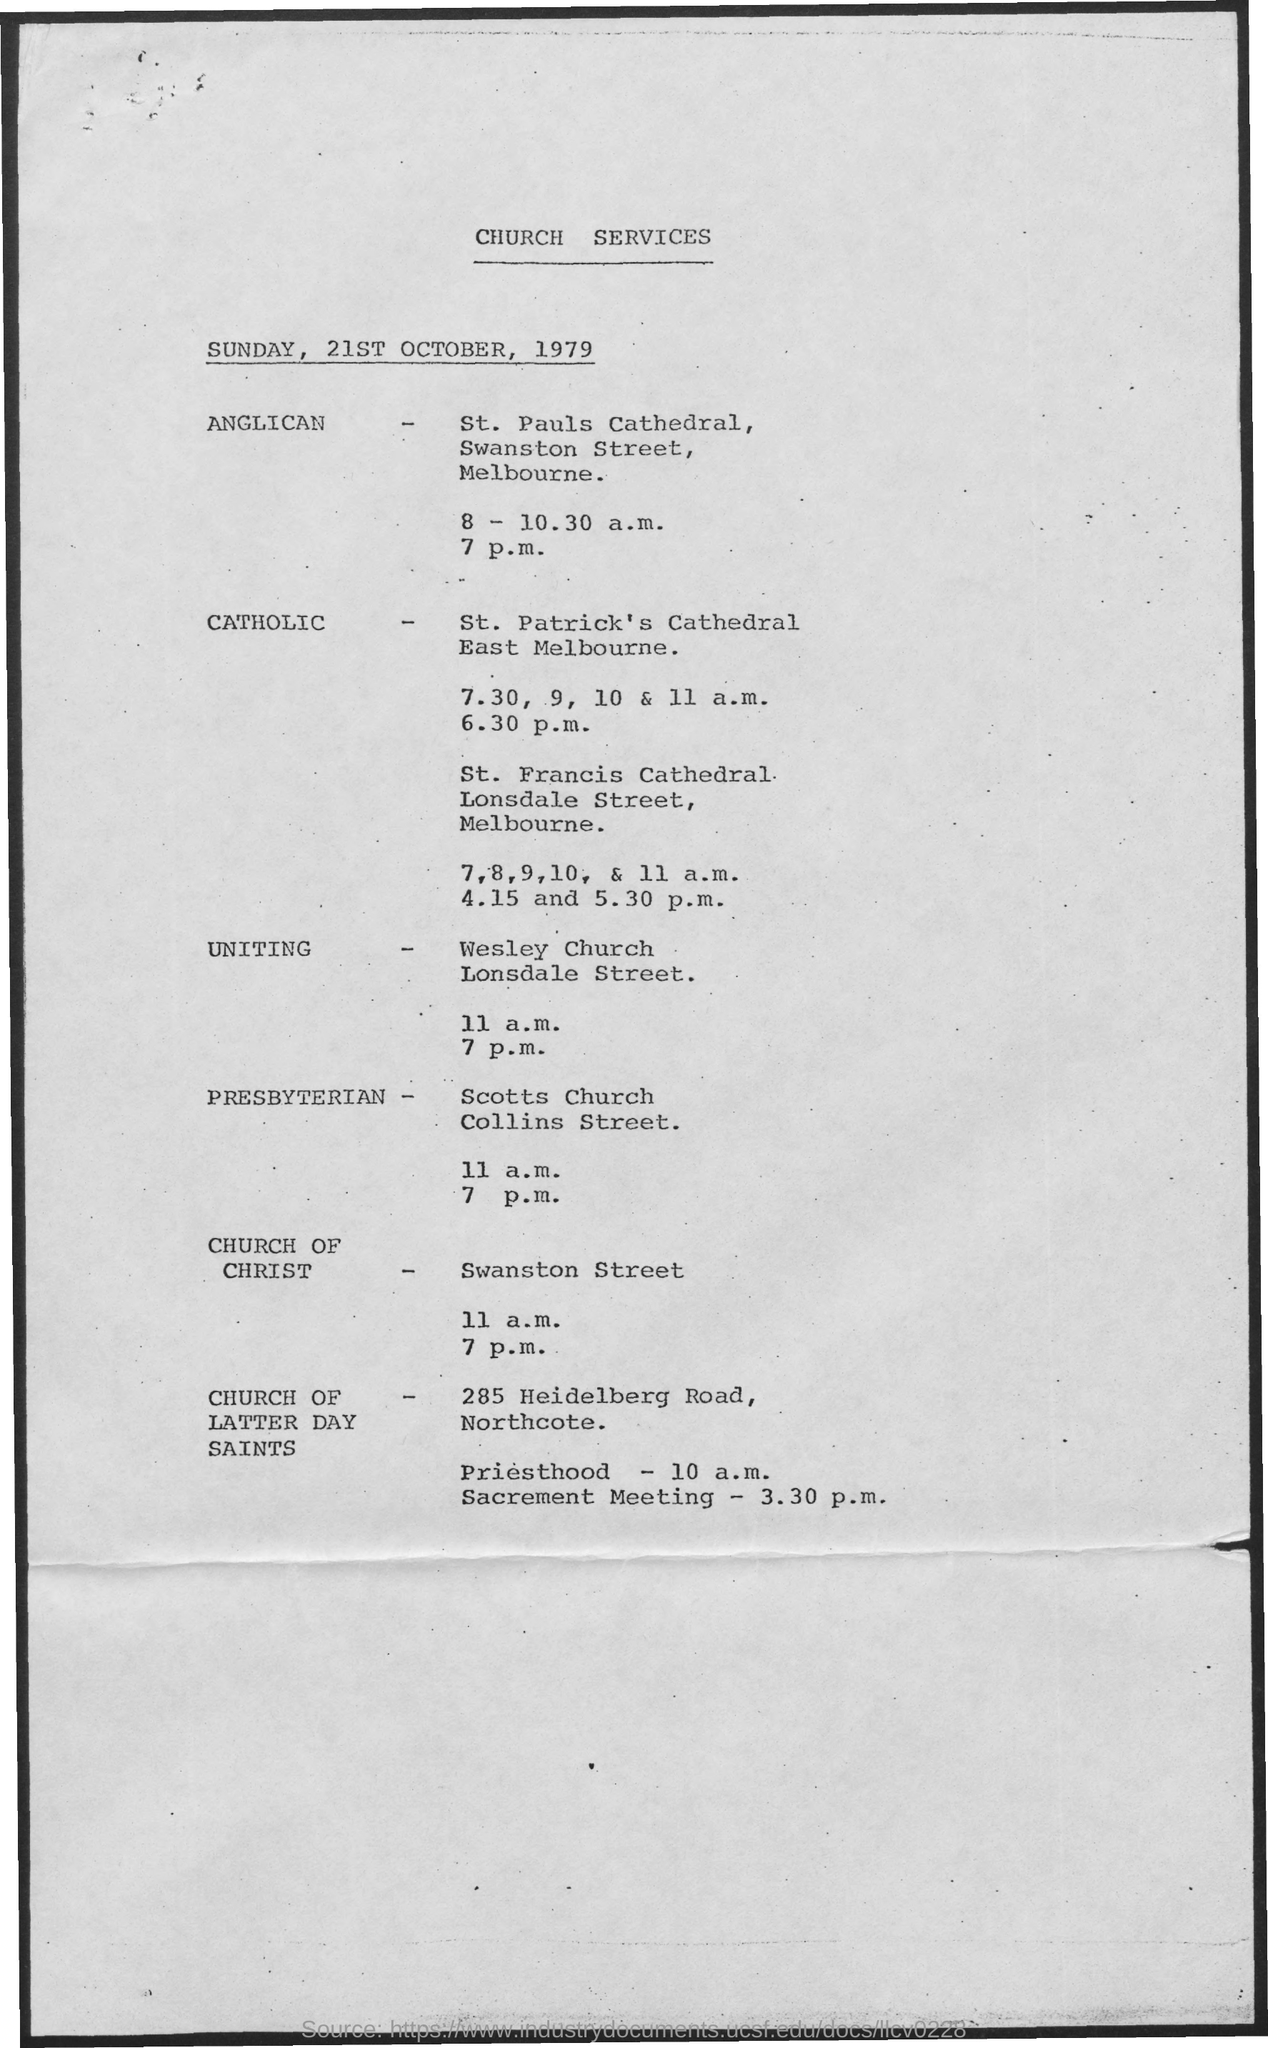Highlight a few significant elements in this photo. The document states that the date mentioned is 21st October, 1979. The Church of Christ can be found at Swanston Street. The heading of the document on top is "Church Services. The document mentions that it is Sunday. 